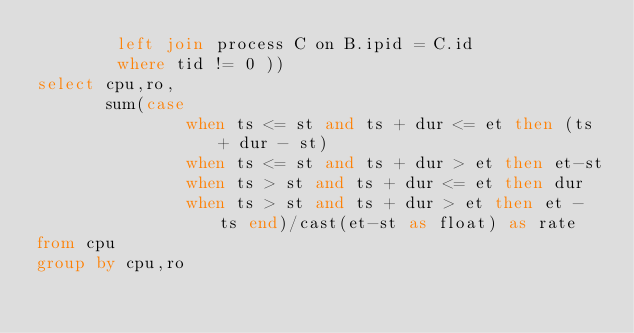<code> <loc_0><loc_0><loc_500><loc_500><_SQL_>        left join process C on B.ipid = C.id
        where tid != 0 ))
select cpu,ro,
       sum(case
               when ts <= st and ts + dur <= et then (ts + dur - st)
               when ts <= st and ts + dur > et then et-st
               when ts > st and ts + dur <= et then dur
               when ts > st and ts + dur > et then et - ts end)/cast(et-st as float) as rate
from cpu
group by cpu,ro</code> 